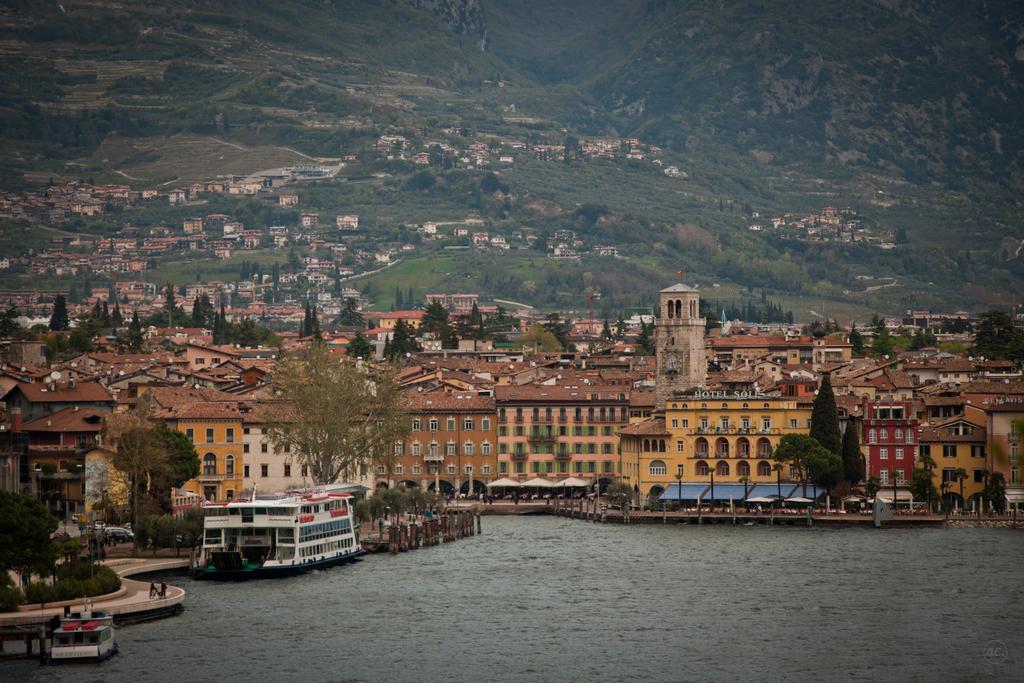How would you summarize this image in a sentence or two? In the picture I can see water, there are boats, buildings, trees and in the background of the picture there are some mountains on which there are some houses, trees. 